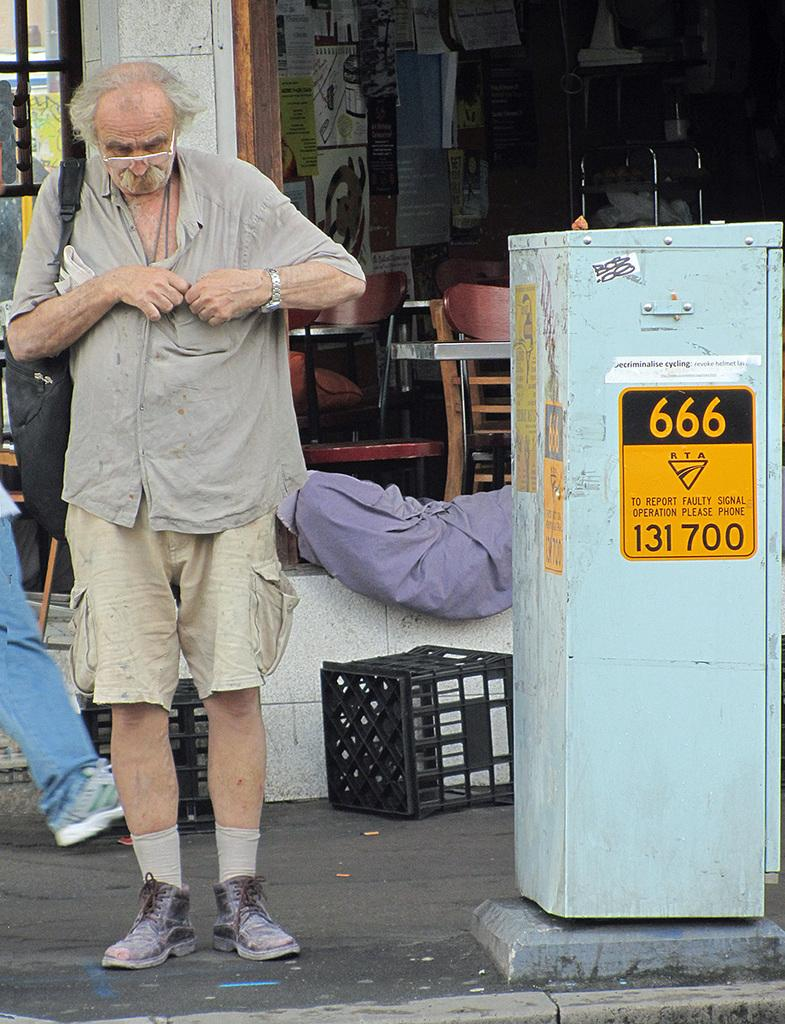What is the main subject of the image? There is an old man standing on the road. What can be seen in the background of the image? There are chairs, baskets, a box, and posters on the wall in the background. What is the weight of the brake on the old man's bicycle in the image? There is no bicycle or brake present in the image, so it is not possible to determine the weight of a brake. 